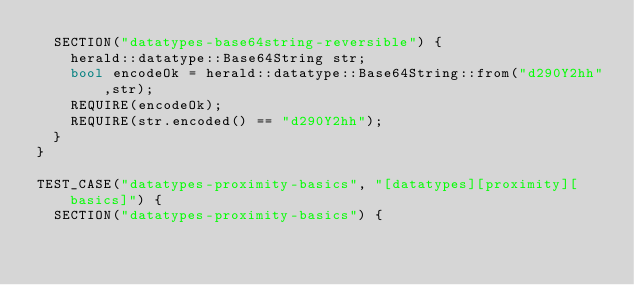<code> <loc_0><loc_0><loc_500><loc_500><_C++_>  SECTION("datatypes-base64string-reversible") {
    herald::datatype::Base64String str;
    bool encodeOk = herald::datatype::Base64String::from("d290Y2hh",str);
    REQUIRE(encodeOk);
    REQUIRE(str.encoded() == "d290Y2hh");
  }
}

TEST_CASE("datatypes-proximity-basics", "[datatypes][proximity][basics]") {
  SECTION("datatypes-proximity-basics") {</code> 